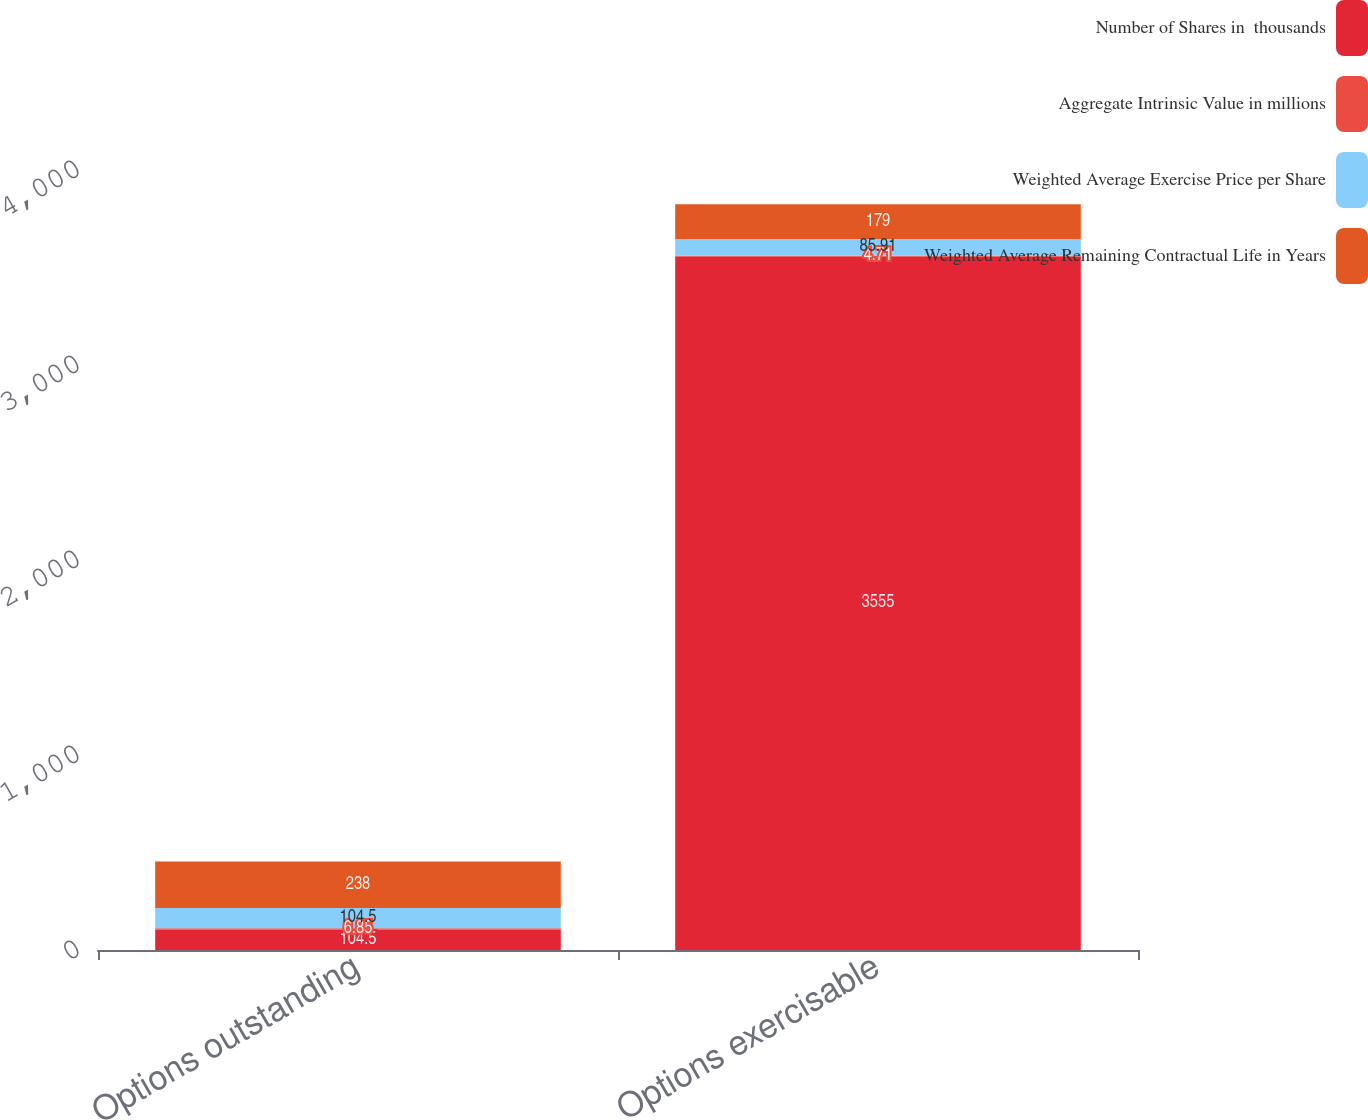Convert chart. <chart><loc_0><loc_0><loc_500><loc_500><stacked_bar_chart><ecel><fcel>Options outstanding<fcel>Options exercisable<nl><fcel>Number of Shares in  thousands<fcel>104.5<fcel>3555<nl><fcel>Aggregate Intrinsic Value in millions<fcel>6.85<fcel>4.71<nl><fcel>Weighted Average Exercise Price per Share<fcel>104.5<fcel>85.91<nl><fcel>Weighted Average Remaining Contractual Life in Years<fcel>238<fcel>179<nl></chart> 